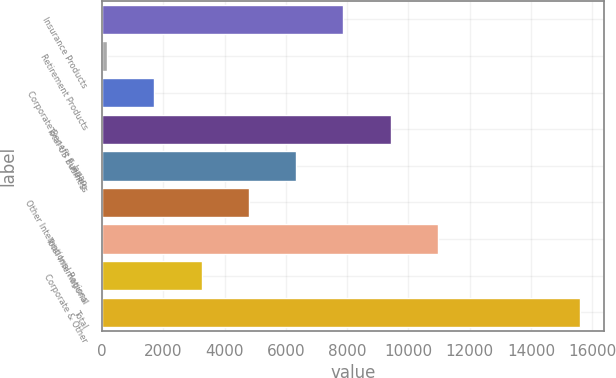Convert chart to OTSL. <chart><loc_0><loc_0><loc_500><loc_500><bar_chart><fcel>Insurance Products<fcel>Retirement Products<fcel>Corporate Benefit Funding<fcel>Total US Business<fcel>Japan<fcel>Other International Regions<fcel>Total International<fcel>Corporate & Other<fcel>Total<nl><fcel>7880<fcel>161<fcel>1704.8<fcel>9423.8<fcel>6336.2<fcel>4792.4<fcel>10967.6<fcel>3248.6<fcel>15599<nl></chart> 